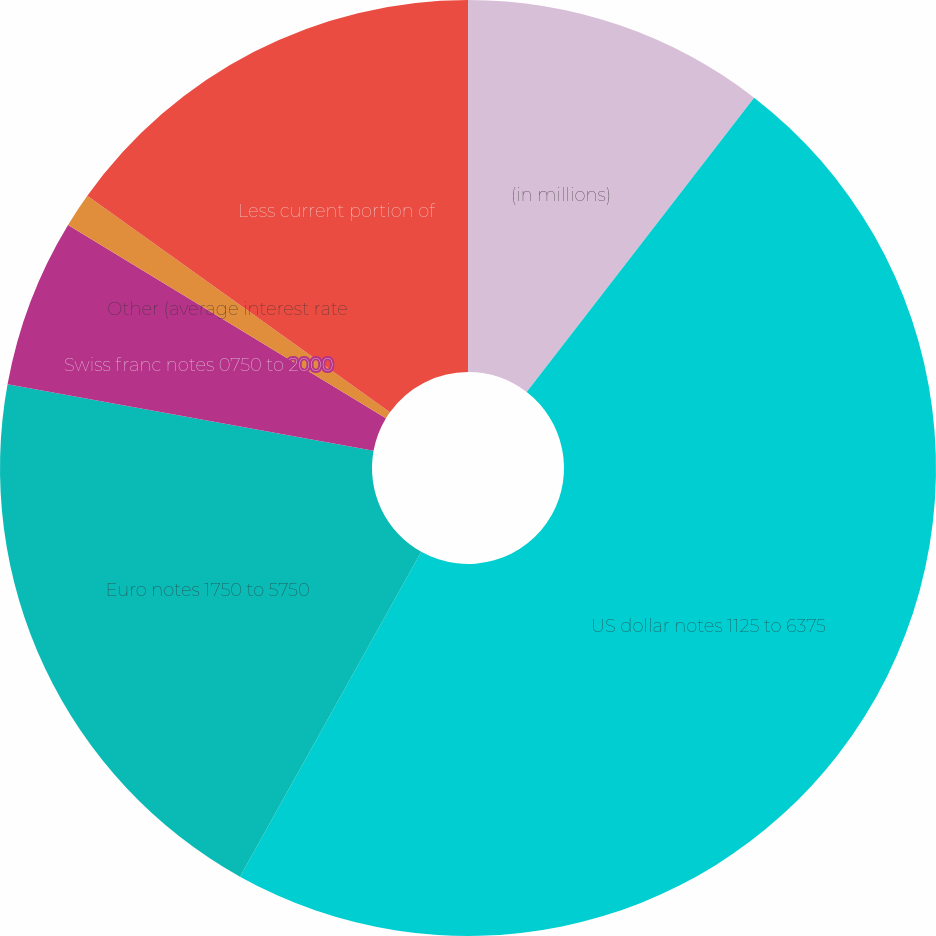<chart> <loc_0><loc_0><loc_500><loc_500><pie_chart><fcel>(in millions)<fcel>US dollar notes 1125 to 6375<fcel>Euro notes 1750 to 5750<fcel>Swiss franc notes 0750 to 2000<fcel>Other (average interest rate<fcel>Less current portion of<nl><fcel>10.47%<fcel>47.63%<fcel>19.76%<fcel>5.83%<fcel>1.19%<fcel>15.12%<nl></chart> 